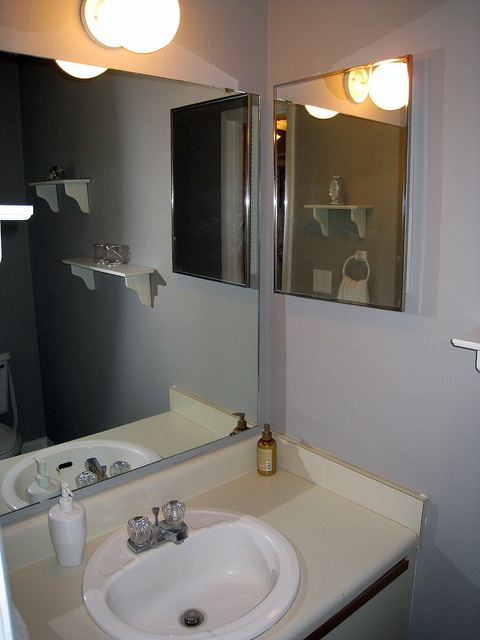Describe the objects in this image and their specific colors. I can see sink in gray, darkgray, and black tones, bottle in gray and darkgray tones, toilet in gray and black tones, and bottle in gray, olive, and maroon tones in this image. 